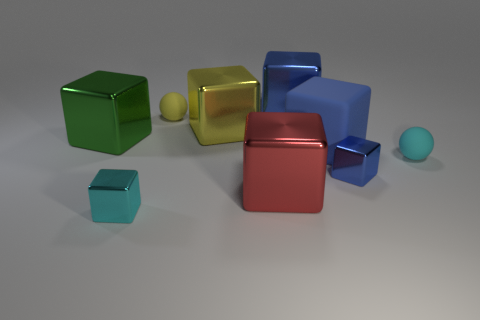Subtract all green cylinders. How many blue blocks are left? 3 Subtract all red blocks. How many blocks are left? 6 Subtract all red blocks. How many blocks are left? 6 Subtract all purple blocks. Subtract all green spheres. How many blocks are left? 7 Subtract all spheres. How many objects are left? 7 Add 6 big green metal cubes. How many big green metal cubes exist? 7 Subtract 0 purple blocks. How many objects are left? 9 Subtract all big yellow objects. Subtract all tiny cyan metallic blocks. How many objects are left? 7 Add 5 red metal cubes. How many red metal cubes are left? 6 